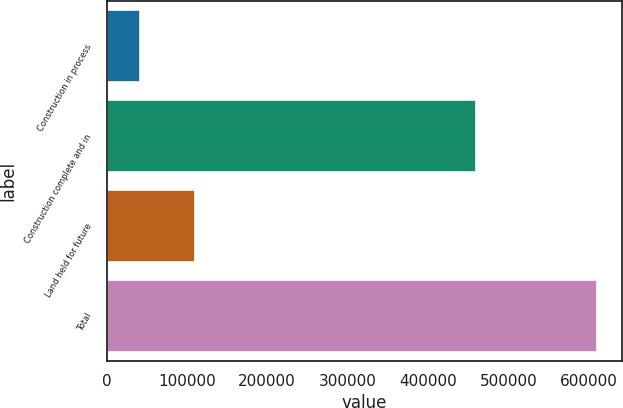Convert chart to OTSL. <chart><loc_0><loc_0><loc_500><loc_500><bar_chart><fcel>Construction in process<fcel>Construction complete and in<fcel>Land held for future<fcel>Total<nl><fcel>41611<fcel>459231<fcel>110090<fcel>610932<nl></chart> 